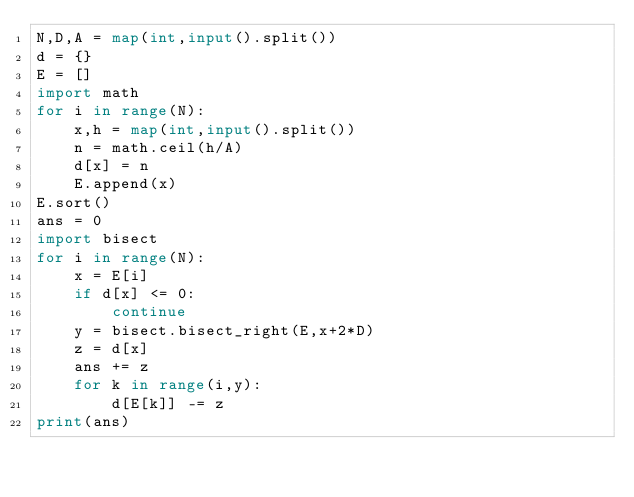Convert code to text. <code><loc_0><loc_0><loc_500><loc_500><_Python_>N,D,A = map(int,input().split())
d = {}
E = []
import math
for i in range(N):
    x,h = map(int,input().split())
    n = math.ceil(h/A)
    d[x] = n
    E.append(x)
E.sort()
ans = 0
import bisect
for i in range(N):
    x = E[i]
    if d[x] <= 0:
        continue
    y = bisect.bisect_right(E,x+2*D)
    z = d[x]
    ans += z
    for k in range(i,y):
        d[E[k]] -= z 
print(ans)</code> 